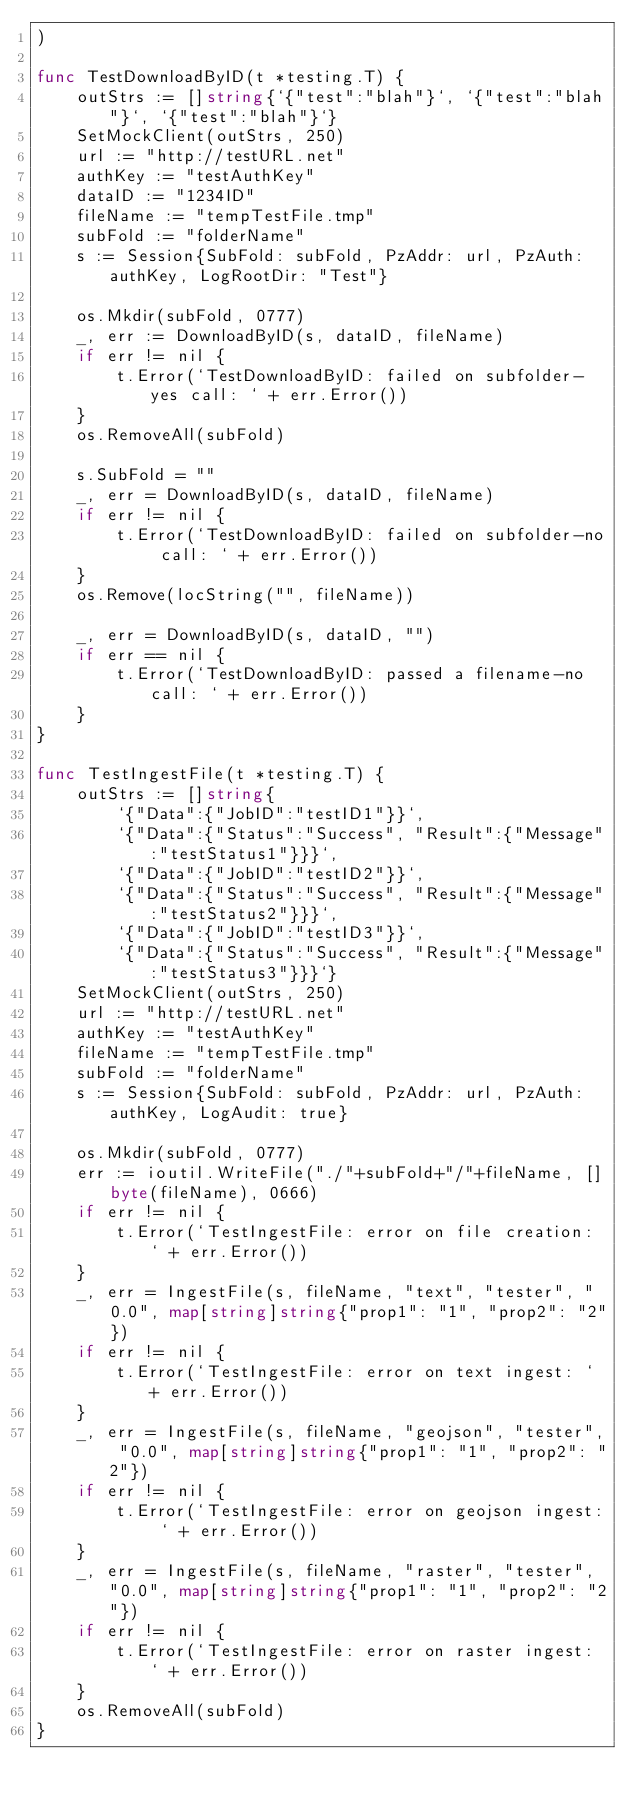Convert code to text. <code><loc_0><loc_0><loc_500><loc_500><_Go_>)

func TestDownloadByID(t *testing.T) {
	outStrs := []string{`{"test":"blah"}`, `{"test":"blah"}`, `{"test":"blah"}`}
	SetMockClient(outStrs, 250)
	url := "http://testURL.net"
	authKey := "testAuthKey"
	dataID := "1234ID"
	fileName := "tempTestFile.tmp"
	subFold := "folderName"
	s := Session{SubFold: subFold, PzAddr: url, PzAuth: authKey, LogRootDir: "Test"}

	os.Mkdir(subFold, 0777)
	_, err := DownloadByID(s, dataID, fileName)
	if err != nil {
		t.Error(`TestDownloadByID: failed on subfolder-yes call: ` + err.Error())
	}
	os.RemoveAll(subFold)

	s.SubFold = ""
	_, err = DownloadByID(s, dataID, fileName)
	if err != nil {
		t.Error(`TestDownloadByID: failed on subfolder-no call: ` + err.Error())
	}
	os.Remove(locString("", fileName))

	_, err = DownloadByID(s, dataID, "")
	if err == nil {
		t.Error(`TestDownloadByID: passed a filename-no call: ` + err.Error())
	}
}

func TestIngestFile(t *testing.T) {
	outStrs := []string{
		`{"Data":{"JobID":"testID1"}}`,
		`{"Data":{"Status":"Success", "Result":{"Message":"testStatus1"}}}`,
		`{"Data":{"JobID":"testID2"}}`,
		`{"Data":{"Status":"Success", "Result":{"Message":"testStatus2"}}}`,
		`{"Data":{"JobID":"testID3"}}`,
		`{"Data":{"Status":"Success", "Result":{"Message":"testStatus3"}}}`}
	SetMockClient(outStrs, 250)
	url := "http://testURL.net"
	authKey := "testAuthKey"
	fileName := "tempTestFile.tmp"
	subFold := "folderName"
	s := Session{SubFold: subFold, PzAddr: url, PzAuth: authKey, LogAudit: true}

	os.Mkdir(subFold, 0777)
	err := ioutil.WriteFile("./"+subFold+"/"+fileName, []byte(fileName), 0666)
	if err != nil {
		t.Error(`TestIngestFile: error on file creation: ` + err.Error())
	}
	_, err = IngestFile(s, fileName, "text", "tester", "0.0", map[string]string{"prop1": "1", "prop2": "2"})
	if err != nil {
		t.Error(`TestIngestFile: error on text ingest: ` + err.Error())
	}
	_, err = IngestFile(s, fileName, "geojson", "tester", "0.0", map[string]string{"prop1": "1", "prop2": "2"})
	if err != nil {
		t.Error(`TestIngestFile: error on geojson ingest: ` + err.Error())
	}
	_, err = IngestFile(s, fileName, "raster", "tester", "0.0", map[string]string{"prop1": "1", "prop2": "2"})
	if err != nil {
		t.Error(`TestIngestFile: error on raster ingest: ` + err.Error())
	}
	os.RemoveAll(subFold)
}
</code> 